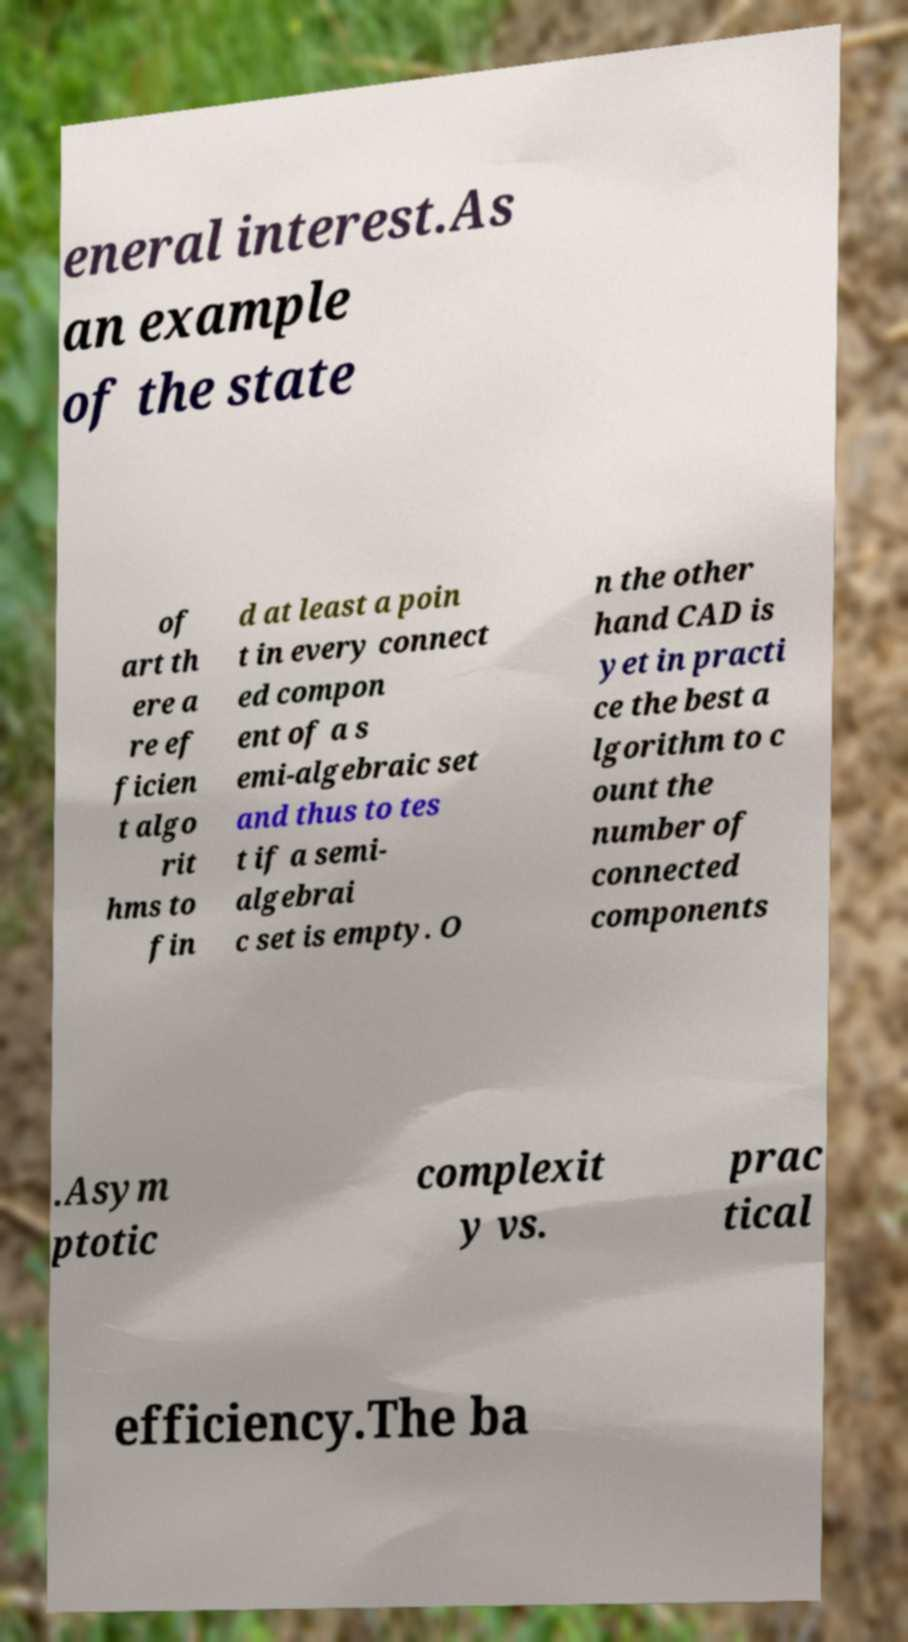Could you extract and type out the text from this image? eneral interest.As an example of the state of art th ere a re ef ficien t algo rit hms to fin d at least a poin t in every connect ed compon ent of a s emi-algebraic set and thus to tes t if a semi- algebrai c set is empty. O n the other hand CAD is yet in practi ce the best a lgorithm to c ount the number of connected components .Asym ptotic complexit y vs. prac tical efficiency.The ba 